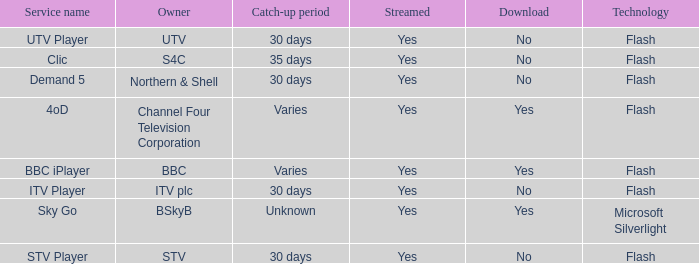What Service Name has UTV as the owner? UTV Player. 